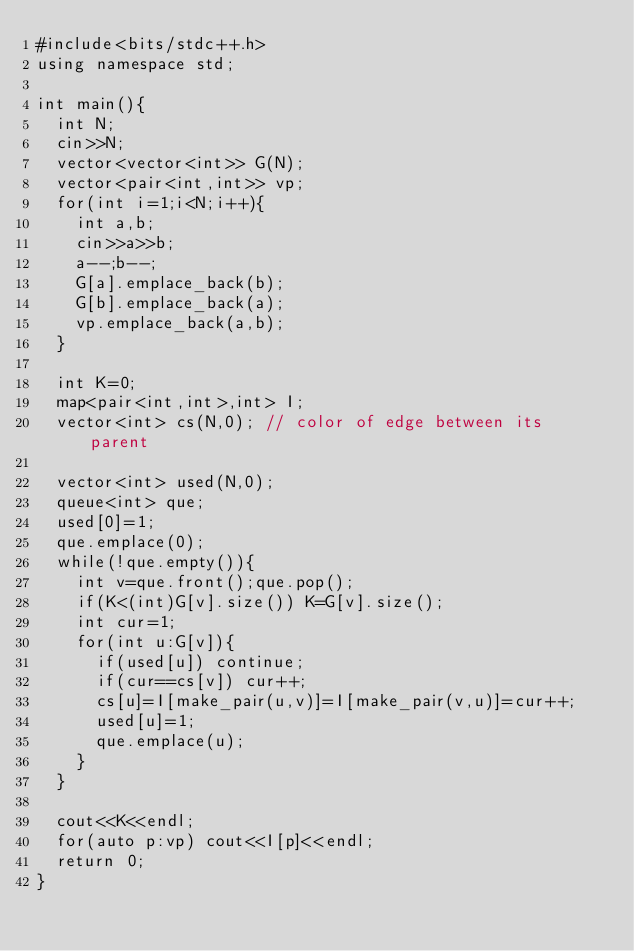<code> <loc_0><loc_0><loc_500><loc_500><_C++_>#include<bits/stdc++.h>
using namespace std;
 
int main(){
  int N;
  cin>>N;
  vector<vector<int>> G(N);
  vector<pair<int,int>> vp;
  for(int i=1;i<N;i++){
    int a,b;
    cin>>a>>b;
    a--;b--;
    G[a].emplace_back(b);
    G[b].emplace_back(a);
    vp.emplace_back(a,b);
  }
 
  int K=0;
  map<pair<int,int>,int> I;
  vector<int> cs(N,0); // color of edge between its parent
 
  vector<int> used(N,0);
  queue<int> que;
  used[0]=1;
  que.emplace(0);
  while(!que.empty()){
    int v=que.front();que.pop();
    if(K<(int)G[v].size()) K=G[v].size();
    int cur=1;
    for(int u:G[v]){
      if(used[u]) continue;
      if(cur==cs[v]) cur++;
      cs[u]=I[make_pair(u,v)]=I[make_pair(v,u)]=cur++;
      used[u]=1;
      que.emplace(u);
    }
  }
 
  cout<<K<<endl;
  for(auto p:vp) cout<<I[p]<<endl;
  return 0;
}</code> 